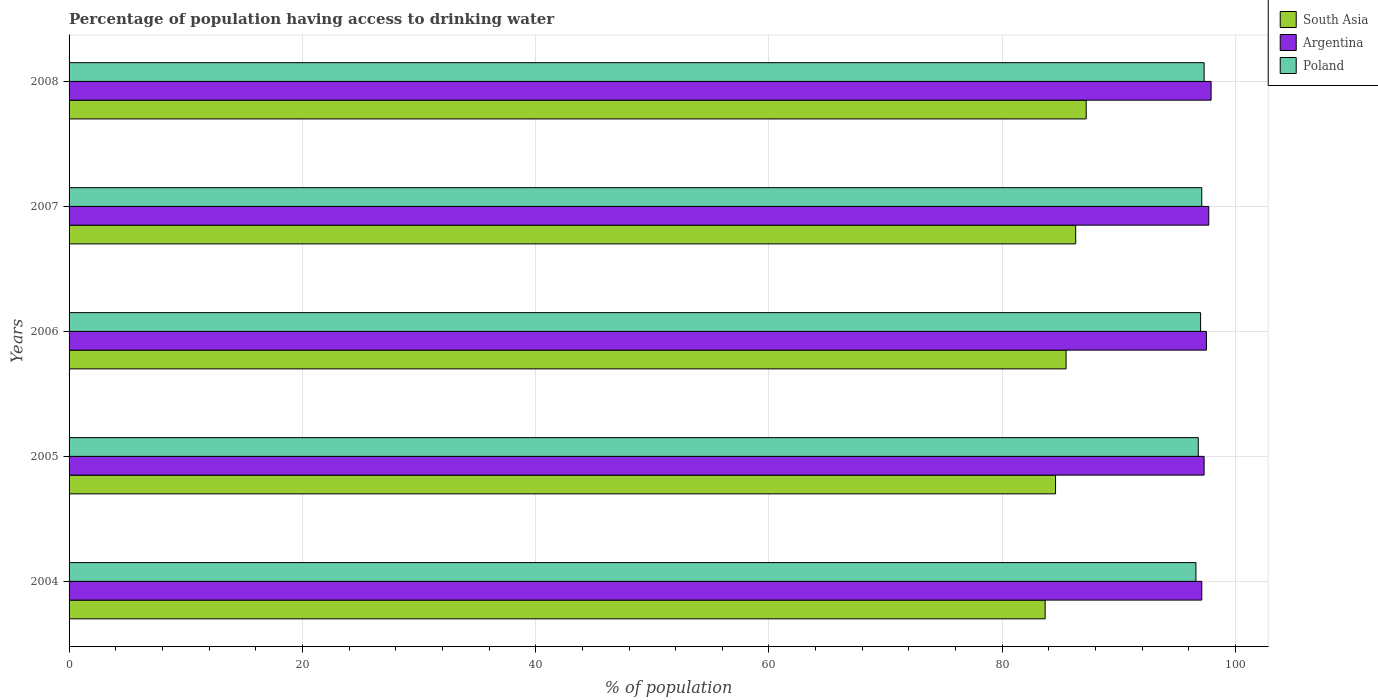How many groups of bars are there?
Offer a terse response. 5. Are the number of bars per tick equal to the number of legend labels?
Your answer should be very brief. Yes. Are the number of bars on each tick of the Y-axis equal?
Your answer should be very brief. Yes. How many bars are there on the 4th tick from the top?
Your response must be concise. 3. How many bars are there on the 1st tick from the bottom?
Your response must be concise. 3. What is the label of the 3rd group of bars from the top?
Offer a very short reply. 2006. In how many cases, is the number of bars for a given year not equal to the number of legend labels?
Your answer should be very brief. 0. What is the percentage of population having access to drinking water in South Asia in 2005?
Provide a short and direct response. 84.56. Across all years, what is the maximum percentage of population having access to drinking water in Poland?
Provide a short and direct response. 97.3. Across all years, what is the minimum percentage of population having access to drinking water in South Asia?
Offer a very short reply. 83.67. What is the total percentage of population having access to drinking water in Poland in the graph?
Provide a short and direct response. 484.8. What is the difference between the percentage of population having access to drinking water in South Asia in 2006 and that in 2008?
Offer a terse response. -1.72. What is the difference between the percentage of population having access to drinking water in Poland in 2004 and the percentage of population having access to drinking water in Argentina in 2005?
Offer a terse response. -0.7. What is the average percentage of population having access to drinking water in Poland per year?
Ensure brevity in your answer.  96.96. In the year 2008, what is the difference between the percentage of population having access to drinking water in Argentina and percentage of population having access to drinking water in Poland?
Give a very brief answer. 0.6. In how many years, is the percentage of population having access to drinking water in Poland greater than 48 %?
Your answer should be very brief. 5. What is the ratio of the percentage of population having access to drinking water in Argentina in 2004 to that in 2005?
Offer a very short reply. 1. Is the percentage of population having access to drinking water in Argentina in 2005 less than that in 2006?
Your response must be concise. Yes. Is the difference between the percentage of population having access to drinking water in Argentina in 2006 and 2008 greater than the difference between the percentage of population having access to drinking water in Poland in 2006 and 2008?
Give a very brief answer. No. What is the difference between the highest and the second highest percentage of population having access to drinking water in South Asia?
Provide a short and direct response. 0.9. What is the difference between the highest and the lowest percentage of population having access to drinking water in South Asia?
Your response must be concise. 3.52. Is it the case that in every year, the sum of the percentage of population having access to drinking water in South Asia and percentage of population having access to drinking water in Poland is greater than the percentage of population having access to drinking water in Argentina?
Provide a succinct answer. Yes. How many bars are there?
Offer a terse response. 15. What is the difference between two consecutive major ticks on the X-axis?
Your response must be concise. 20. Are the values on the major ticks of X-axis written in scientific E-notation?
Keep it short and to the point. No. Does the graph contain any zero values?
Your response must be concise. No. Does the graph contain grids?
Offer a very short reply. Yes. Where does the legend appear in the graph?
Provide a short and direct response. Top right. How many legend labels are there?
Your answer should be very brief. 3. How are the legend labels stacked?
Provide a short and direct response. Vertical. What is the title of the graph?
Ensure brevity in your answer.  Percentage of population having access to drinking water. What is the label or title of the X-axis?
Ensure brevity in your answer.  % of population. What is the % of population in South Asia in 2004?
Offer a very short reply. 83.67. What is the % of population in Argentina in 2004?
Ensure brevity in your answer.  97.1. What is the % of population in Poland in 2004?
Your response must be concise. 96.6. What is the % of population of South Asia in 2005?
Your answer should be very brief. 84.56. What is the % of population in Argentina in 2005?
Your answer should be very brief. 97.3. What is the % of population of Poland in 2005?
Keep it short and to the point. 96.8. What is the % of population in South Asia in 2006?
Your answer should be compact. 85.47. What is the % of population in Argentina in 2006?
Keep it short and to the point. 97.5. What is the % of population of Poland in 2006?
Offer a terse response. 97. What is the % of population of South Asia in 2007?
Your answer should be compact. 86.29. What is the % of population of Argentina in 2007?
Offer a terse response. 97.7. What is the % of population of Poland in 2007?
Your answer should be very brief. 97.1. What is the % of population of South Asia in 2008?
Give a very brief answer. 87.19. What is the % of population of Argentina in 2008?
Ensure brevity in your answer.  97.9. What is the % of population in Poland in 2008?
Offer a terse response. 97.3. Across all years, what is the maximum % of population in South Asia?
Your answer should be compact. 87.19. Across all years, what is the maximum % of population in Argentina?
Offer a very short reply. 97.9. Across all years, what is the maximum % of population of Poland?
Provide a short and direct response. 97.3. Across all years, what is the minimum % of population in South Asia?
Your answer should be compact. 83.67. Across all years, what is the minimum % of population of Argentina?
Offer a terse response. 97.1. Across all years, what is the minimum % of population of Poland?
Your response must be concise. 96.6. What is the total % of population of South Asia in the graph?
Offer a very short reply. 427.19. What is the total % of population in Argentina in the graph?
Provide a succinct answer. 487.5. What is the total % of population of Poland in the graph?
Give a very brief answer. 484.8. What is the difference between the % of population in South Asia in 2004 and that in 2005?
Your answer should be compact. -0.89. What is the difference between the % of population of Argentina in 2004 and that in 2005?
Give a very brief answer. -0.2. What is the difference between the % of population in South Asia in 2004 and that in 2006?
Your response must be concise. -1.8. What is the difference between the % of population in Poland in 2004 and that in 2006?
Provide a succinct answer. -0.4. What is the difference between the % of population in South Asia in 2004 and that in 2007?
Give a very brief answer. -2.62. What is the difference between the % of population of Poland in 2004 and that in 2007?
Your answer should be compact. -0.5. What is the difference between the % of population in South Asia in 2004 and that in 2008?
Keep it short and to the point. -3.52. What is the difference between the % of population of Poland in 2004 and that in 2008?
Provide a succinct answer. -0.7. What is the difference between the % of population in South Asia in 2005 and that in 2006?
Make the answer very short. -0.9. What is the difference between the % of population in Argentina in 2005 and that in 2006?
Your answer should be compact. -0.2. What is the difference between the % of population of South Asia in 2005 and that in 2007?
Ensure brevity in your answer.  -1.73. What is the difference between the % of population of Poland in 2005 and that in 2007?
Offer a terse response. -0.3. What is the difference between the % of population of South Asia in 2005 and that in 2008?
Your response must be concise. -2.63. What is the difference between the % of population of Poland in 2005 and that in 2008?
Ensure brevity in your answer.  -0.5. What is the difference between the % of population in South Asia in 2006 and that in 2007?
Offer a very short reply. -0.82. What is the difference between the % of population in Argentina in 2006 and that in 2007?
Keep it short and to the point. -0.2. What is the difference between the % of population in South Asia in 2006 and that in 2008?
Make the answer very short. -1.72. What is the difference between the % of population of Argentina in 2006 and that in 2008?
Offer a terse response. -0.4. What is the difference between the % of population in South Asia in 2007 and that in 2008?
Provide a succinct answer. -0.9. What is the difference between the % of population of South Asia in 2004 and the % of population of Argentina in 2005?
Offer a very short reply. -13.63. What is the difference between the % of population of South Asia in 2004 and the % of population of Poland in 2005?
Offer a very short reply. -13.13. What is the difference between the % of population in South Asia in 2004 and the % of population in Argentina in 2006?
Offer a very short reply. -13.83. What is the difference between the % of population of South Asia in 2004 and the % of population of Poland in 2006?
Give a very brief answer. -13.33. What is the difference between the % of population in Argentina in 2004 and the % of population in Poland in 2006?
Make the answer very short. 0.1. What is the difference between the % of population of South Asia in 2004 and the % of population of Argentina in 2007?
Your response must be concise. -14.03. What is the difference between the % of population of South Asia in 2004 and the % of population of Poland in 2007?
Provide a short and direct response. -13.43. What is the difference between the % of population in Argentina in 2004 and the % of population in Poland in 2007?
Offer a very short reply. 0. What is the difference between the % of population in South Asia in 2004 and the % of population in Argentina in 2008?
Offer a very short reply. -14.23. What is the difference between the % of population of South Asia in 2004 and the % of population of Poland in 2008?
Your answer should be very brief. -13.63. What is the difference between the % of population of South Asia in 2005 and the % of population of Argentina in 2006?
Ensure brevity in your answer.  -12.94. What is the difference between the % of population of South Asia in 2005 and the % of population of Poland in 2006?
Offer a very short reply. -12.44. What is the difference between the % of population in Argentina in 2005 and the % of population in Poland in 2006?
Ensure brevity in your answer.  0.3. What is the difference between the % of population of South Asia in 2005 and the % of population of Argentina in 2007?
Make the answer very short. -13.13. What is the difference between the % of population in South Asia in 2005 and the % of population in Poland in 2007?
Your answer should be compact. -12.54. What is the difference between the % of population of South Asia in 2005 and the % of population of Argentina in 2008?
Keep it short and to the point. -13.34. What is the difference between the % of population of South Asia in 2005 and the % of population of Poland in 2008?
Ensure brevity in your answer.  -12.73. What is the difference between the % of population in South Asia in 2006 and the % of population in Argentina in 2007?
Your response must be concise. -12.23. What is the difference between the % of population of South Asia in 2006 and the % of population of Poland in 2007?
Ensure brevity in your answer.  -11.63. What is the difference between the % of population in South Asia in 2006 and the % of population in Argentina in 2008?
Your answer should be compact. -12.43. What is the difference between the % of population of South Asia in 2006 and the % of population of Poland in 2008?
Offer a very short reply. -11.83. What is the difference between the % of population of South Asia in 2007 and the % of population of Argentina in 2008?
Offer a terse response. -11.61. What is the difference between the % of population in South Asia in 2007 and the % of population in Poland in 2008?
Your answer should be compact. -11.01. What is the average % of population of South Asia per year?
Give a very brief answer. 85.44. What is the average % of population in Argentina per year?
Your answer should be very brief. 97.5. What is the average % of population in Poland per year?
Your answer should be very brief. 96.96. In the year 2004, what is the difference between the % of population of South Asia and % of population of Argentina?
Provide a short and direct response. -13.43. In the year 2004, what is the difference between the % of population of South Asia and % of population of Poland?
Offer a very short reply. -12.93. In the year 2005, what is the difference between the % of population in South Asia and % of population in Argentina?
Your response must be concise. -12.73. In the year 2005, what is the difference between the % of population of South Asia and % of population of Poland?
Your answer should be very brief. -12.23. In the year 2006, what is the difference between the % of population in South Asia and % of population in Argentina?
Provide a succinct answer. -12.03. In the year 2006, what is the difference between the % of population in South Asia and % of population in Poland?
Offer a very short reply. -11.53. In the year 2007, what is the difference between the % of population of South Asia and % of population of Argentina?
Give a very brief answer. -11.41. In the year 2007, what is the difference between the % of population of South Asia and % of population of Poland?
Offer a very short reply. -10.81. In the year 2008, what is the difference between the % of population of South Asia and % of population of Argentina?
Your response must be concise. -10.71. In the year 2008, what is the difference between the % of population in South Asia and % of population in Poland?
Provide a succinct answer. -10.11. In the year 2008, what is the difference between the % of population in Argentina and % of population in Poland?
Give a very brief answer. 0.6. What is the ratio of the % of population in South Asia in 2004 to that in 2005?
Make the answer very short. 0.99. What is the ratio of the % of population in Argentina in 2004 to that in 2005?
Your response must be concise. 1. What is the ratio of the % of population of South Asia in 2004 to that in 2006?
Offer a terse response. 0.98. What is the ratio of the % of population of South Asia in 2004 to that in 2007?
Your answer should be very brief. 0.97. What is the ratio of the % of population of Poland in 2004 to that in 2007?
Your answer should be compact. 0.99. What is the ratio of the % of population of South Asia in 2004 to that in 2008?
Ensure brevity in your answer.  0.96. What is the ratio of the % of population in Poland in 2004 to that in 2008?
Your answer should be compact. 0.99. What is the ratio of the % of population of South Asia in 2005 to that in 2006?
Ensure brevity in your answer.  0.99. What is the ratio of the % of population of Argentina in 2005 to that in 2006?
Offer a terse response. 1. What is the ratio of the % of population in Poland in 2005 to that in 2007?
Your answer should be compact. 1. What is the ratio of the % of population in South Asia in 2005 to that in 2008?
Offer a very short reply. 0.97. What is the ratio of the % of population of Poland in 2005 to that in 2008?
Your response must be concise. 0.99. What is the ratio of the % of population in South Asia in 2006 to that in 2007?
Your answer should be compact. 0.99. What is the ratio of the % of population of Argentina in 2006 to that in 2007?
Provide a succinct answer. 1. What is the ratio of the % of population in South Asia in 2006 to that in 2008?
Your answer should be very brief. 0.98. What is the ratio of the % of population of Argentina in 2006 to that in 2008?
Your answer should be very brief. 1. What is the ratio of the % of population in Poland in 2006 to that in 2008?
Your answer should be compact. 1. What is the ratio of the % of population of South Asia in 2007 to that in 2008?
Ensure brevity in your answer.  0.99. What is the ratio of the % of population in Argentina in 2007 to that in 2008?
Your response must be concise. 1. What is the ratio of the % of population of Poland in 2007 to that in 2008?
Offer a very short reply. 1. What is the difference between the highest and the second highest % of population of South Asia?
Your answer should be very brief. 0.9. What is the difference between the highest and the lowest % of population of South Asia?
Your response must be concise. 3.52. What is the difference between the highest and the lowest % of population in Argentina?
Your answer should be compact. 0.8. 